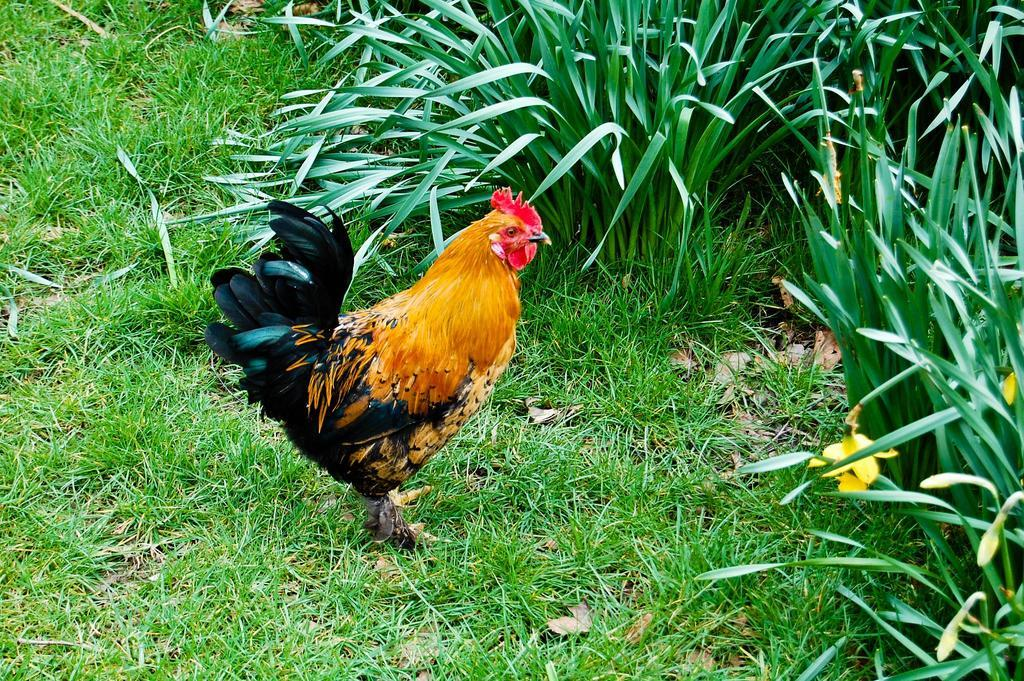What animal is present in the image? There is a hen in the image. Where is the hen located? The hen is standing on a grass path. What can be seen behind the hen? There are plants visible behind the hen. What type of ornament is hanging from the hen's neck in the image? There is no ornament hanging from the hen's neck in the image; the hen is not wearing any accessories. 